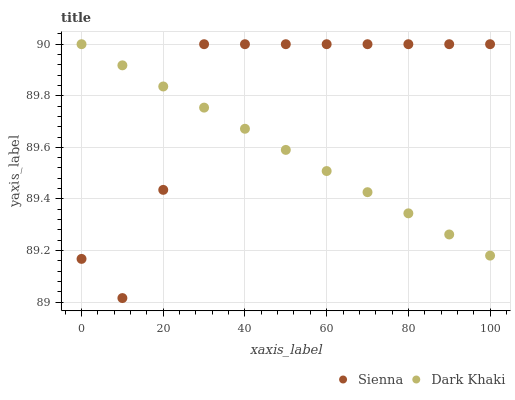Does Dark Khaki have the minimum area under the curve?
Answer yes or no. Yes. Does Sienna have the maximum area under the curve?
Answer yes or no. Yes. Does Dark Khaki have the maximum area under the curve?
Answer yes or no. No. Is Dark Khaki the smoothest?
Answer yes or no. Yes. Is Sienna the roughest?
Answer yes or no. Yes. Is Dark Khaki the roughest?
Answer yes or no. No. Does Sienna have the lowest value?
Answer yes or no. Yes. Does Dark Khaki have the lowest value?
Answer yes or no. No. Does Dark Khaki have the highest value?
Answer yes or no. Yes. Does Dark Khaki intersect Sienna?
Answer yes or no. Yes. Is Dark Khaki less than Sienna?
Answer yes or no. No. Is Dark Khaki greater than Sienna?
Answer yes or no. No. 